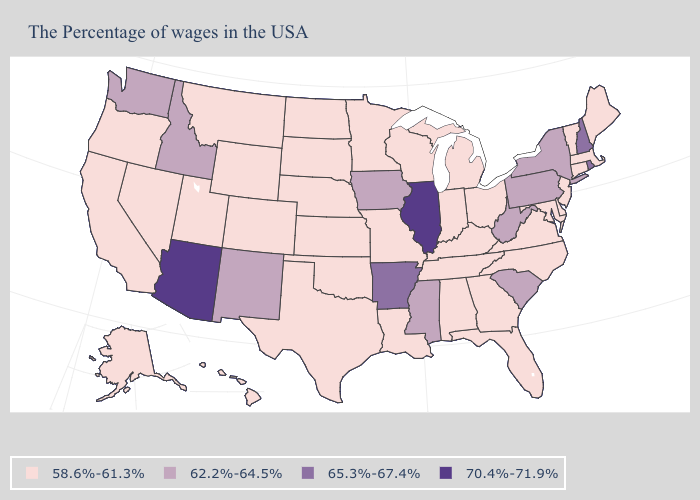Name the states that have a value in the range 65.3%-67.4%?
Short answer required. Rhode Island, New Hampshire, Arkansas. Which states hav the highest value in the South?
Write a very short answer. Arkansas. What is the value of New Mexico?
Answer briefly. 62.2%-64.5%. What is the highest value in the MidWest ?
Keep it brief. 70.4%-71.9%. What is the value of Nebraska?
Give a very brief answer. 58.6%-61.3%. What is the value of Washington?
Keep it brief. 62.2%-64.5%. What is the highest value in the USA?
Give a very brief answer. 70.4%-71.9%. Among the states that border Pennsylvania , which have the lowest value?
Concise answer only. New Jersey, Delaware, Maryland, Ohio. Name the states that have a value in the range 58.6%-61.3%?
Quick response, please. Maine, Massachusetts, Vermont, Connecticut, New Jersey, Delaware, Maryland, Virginia, North Carolina, Ohio, Florida, Georgia, Michigan, Kentucky, Indiana, Alabama, Tennessee, Wisconsin, Louisiana, Missouri, Minnesota, Kansas, Nebraska, Oklahoma, Texas, South Dakota, North Dakota, Wyoming, Colorado, Utah, Montana, Nevada, California, Oregon, Alaska, Hawaii. Does the map have missing data?
Write a very short answer. No. Name the states that have a value in the range 62.2%-64.5%?
Be succinct. New York, Pennsylvania, South Carolina, West Virginia, Mississippi, Iowa, New Mexico, Idaho, Washington. Name the states that have a value in the range 58.6%-61.3%?
Give a very brief answer. Maine, Massachusetts, Vermont, Connecticut, New Jersey, Delaware, Maryland, Virginia, North Carolina, Ohio, Florida, Georgia, Michigan, Kentucky, Indiana, Alabama, Tennessee, Wisconsin, Louisiana, Missouri, Minnesota, Kansas, Nebraska, Oklahoma, Texas, South Dakota, North Dakota, Wyoming, Colorado, Utah, Montana, Nevada, California, Oregon, Alaska, Hawaii. What is the value of Alaska?
Keep it brief. 58.6%-61.3%. What is the highest value in the USA?
Be succinct. 70.4%-71.9%. What is the value of New York?
Concise answer only. 62.2%-64.5%. 